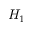Convert formula to latex. <formula><loc_0><loc_0><loc_500><loc_500>H _ { 1 }</formula> 